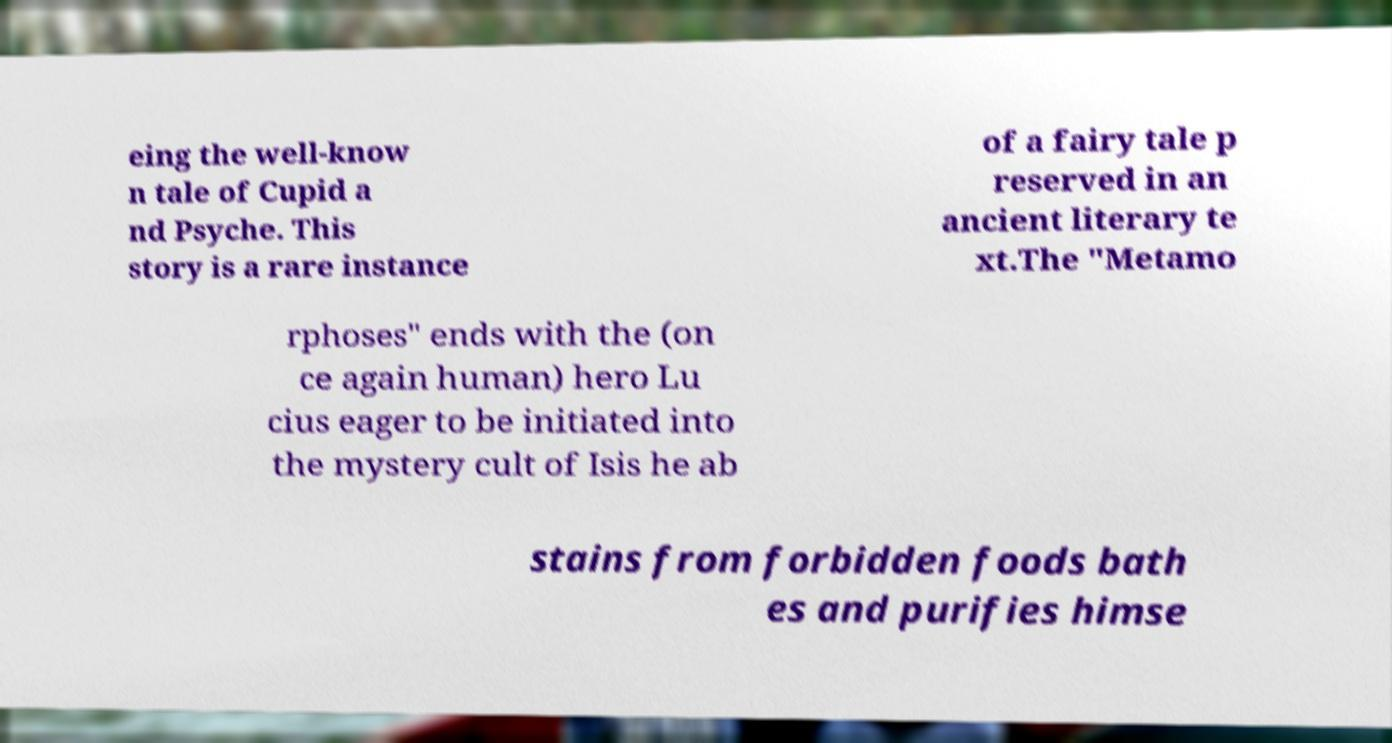Can you read and provide the text displayed in the image?This photo seems to have some interesting text. Can you extract and type it out for me? eing the well-know n tale of Cupid a nd Psyche. This story is a rare instance of a fairy tale p reserved in an ancient literary te xt.The "Metamo rphoses" ends with the (on ce again human) hero Lu cius eager to be initiated into the mystery cult of Isis he ab stains from forbidden foods bath es and purifies himse 